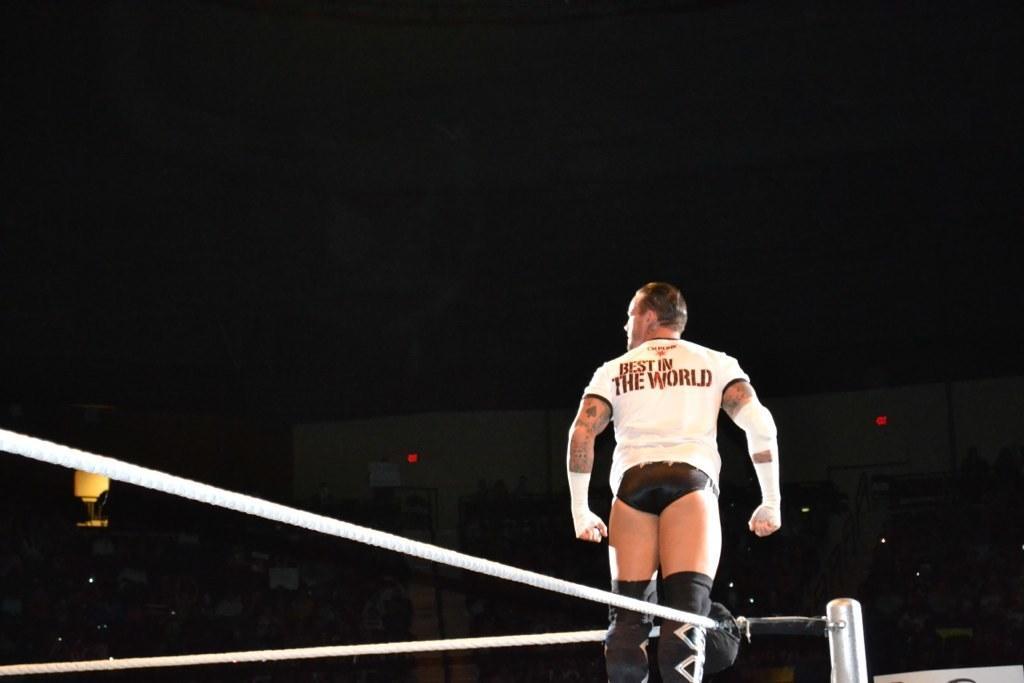In one or two sentences, can you explain what this image depicts? In this picture we can see a man standing. There is a rope and a pole. We can see a building, few lights and a parachute in the background. 